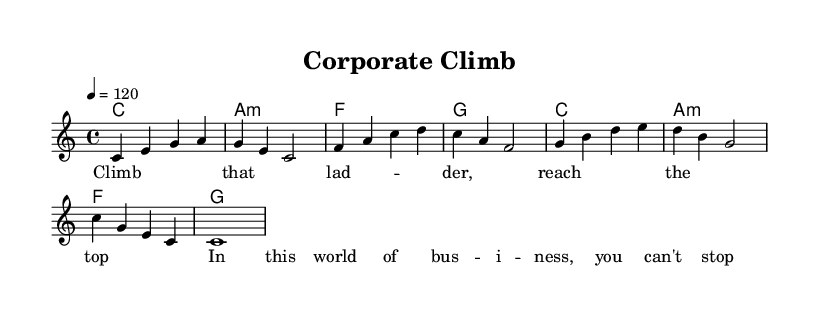What is the key signature of this music? The key signature is C major, which has no sharps or flats.
Answer: C major What is the time signature of this music? The time signature shown is 4/4, indicating four beats per measure.
Answer: 4/4 What is the tempo marking in beats per minute? The tempo marking is indicated as 120, meaning the piece is played at 120 beats per minute.
Answer: 120 How many measures are in the melody section? The melody consists of 8 measures based on counting the individual measures written out.
Answer: 8 What is the main theme or lyric phrase of the song? The main lyric phrase focuses on achieving success in business, articulated in the words about climbing and reaching the top.
Answer: Climb that ladder What chord follows the F chord in the harmonies? The harmony sequence shows that the G chord follows the F chord in the progression.
Answer: G How many different chords are used in the entire score? The score features three unique chords: C, A minor, F, and G; a total of four unique chords can be identified.
Answer: 4 